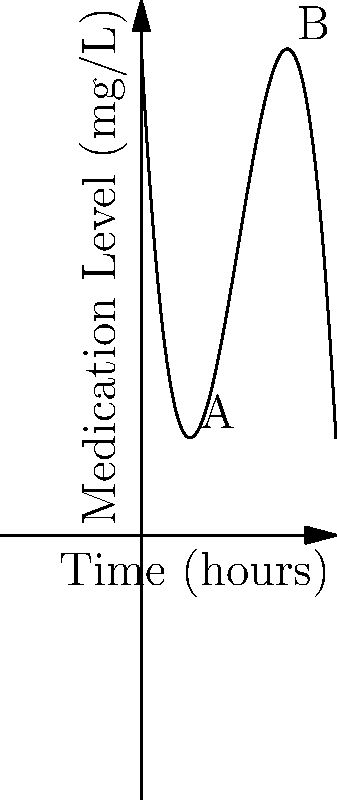Based on your successful surgery experience, you understand the importance of proper medication dosage. The graph shows the concentration of a post-surgery pain medication in a patient's bloodstream over time. The function that models this concentration is given by $f(t) = -0.5t^3 + 6t^2 - 18t + 20$, where $t$ is time in hours and $f(t)$ is the medication level in mg/L. At what time does the medication reach its peak concentration, and what is this maximum concentration? To find the peak concentration, we need to determine the maximum point of the function. This occurs where the derivative of the function equals zero.

1) First, let's find the derivative of $f(t)$:
   $f'(t) = -1.5t^2 + 12t - 18$

2) Set the derivative equal to zero and solve:
   $-1.5t^2 + 12t - 18 = 0$
   
3) This is a quadratic equation. We can solve it using the quadratic formula:
   $t = \frac{-b \pm \sqrt{b^2 - 4ac}}{2a}$
   where $a = -1.5$, $b = 12$, and $c = -18$

4) Plugging in these values:
   $t = \frac{-12 \pm \sqrt{12^2 - 4(-1.5)(-18)}}{2(-1.5)}$
   $= \frac{-12 \pm \sqrt{144 - 108}}{-3}$
   $= \frac{-12 \pm \sqrt{36}}{-3}$
   $= \frac{-12 \pm 6}{-3}$

5) This gives us two solutions:
   $t = \frac{-12 + 6}{-3} = 2$ or $t = \frac{-12 - 6}{-3} = 6$

6) The second solution, $t = 6$, corresponds to a minimum, so the maximum occurs at $t = 2$ hours.

7) To find the maximum concentration, we plug $t = 2$ into our original function:
   $f(2) = -0.5(2)^3 + 6(2)^2 - 18(2) + 20$
   $= -4 + 24 - 36 + 20 = 4$ mg/L

Therefore, the medication reaches its peak concentration after 2 hours, and the maximum concentration is 4 mg/L.
Answer: 2 hours; 4 mg/L 